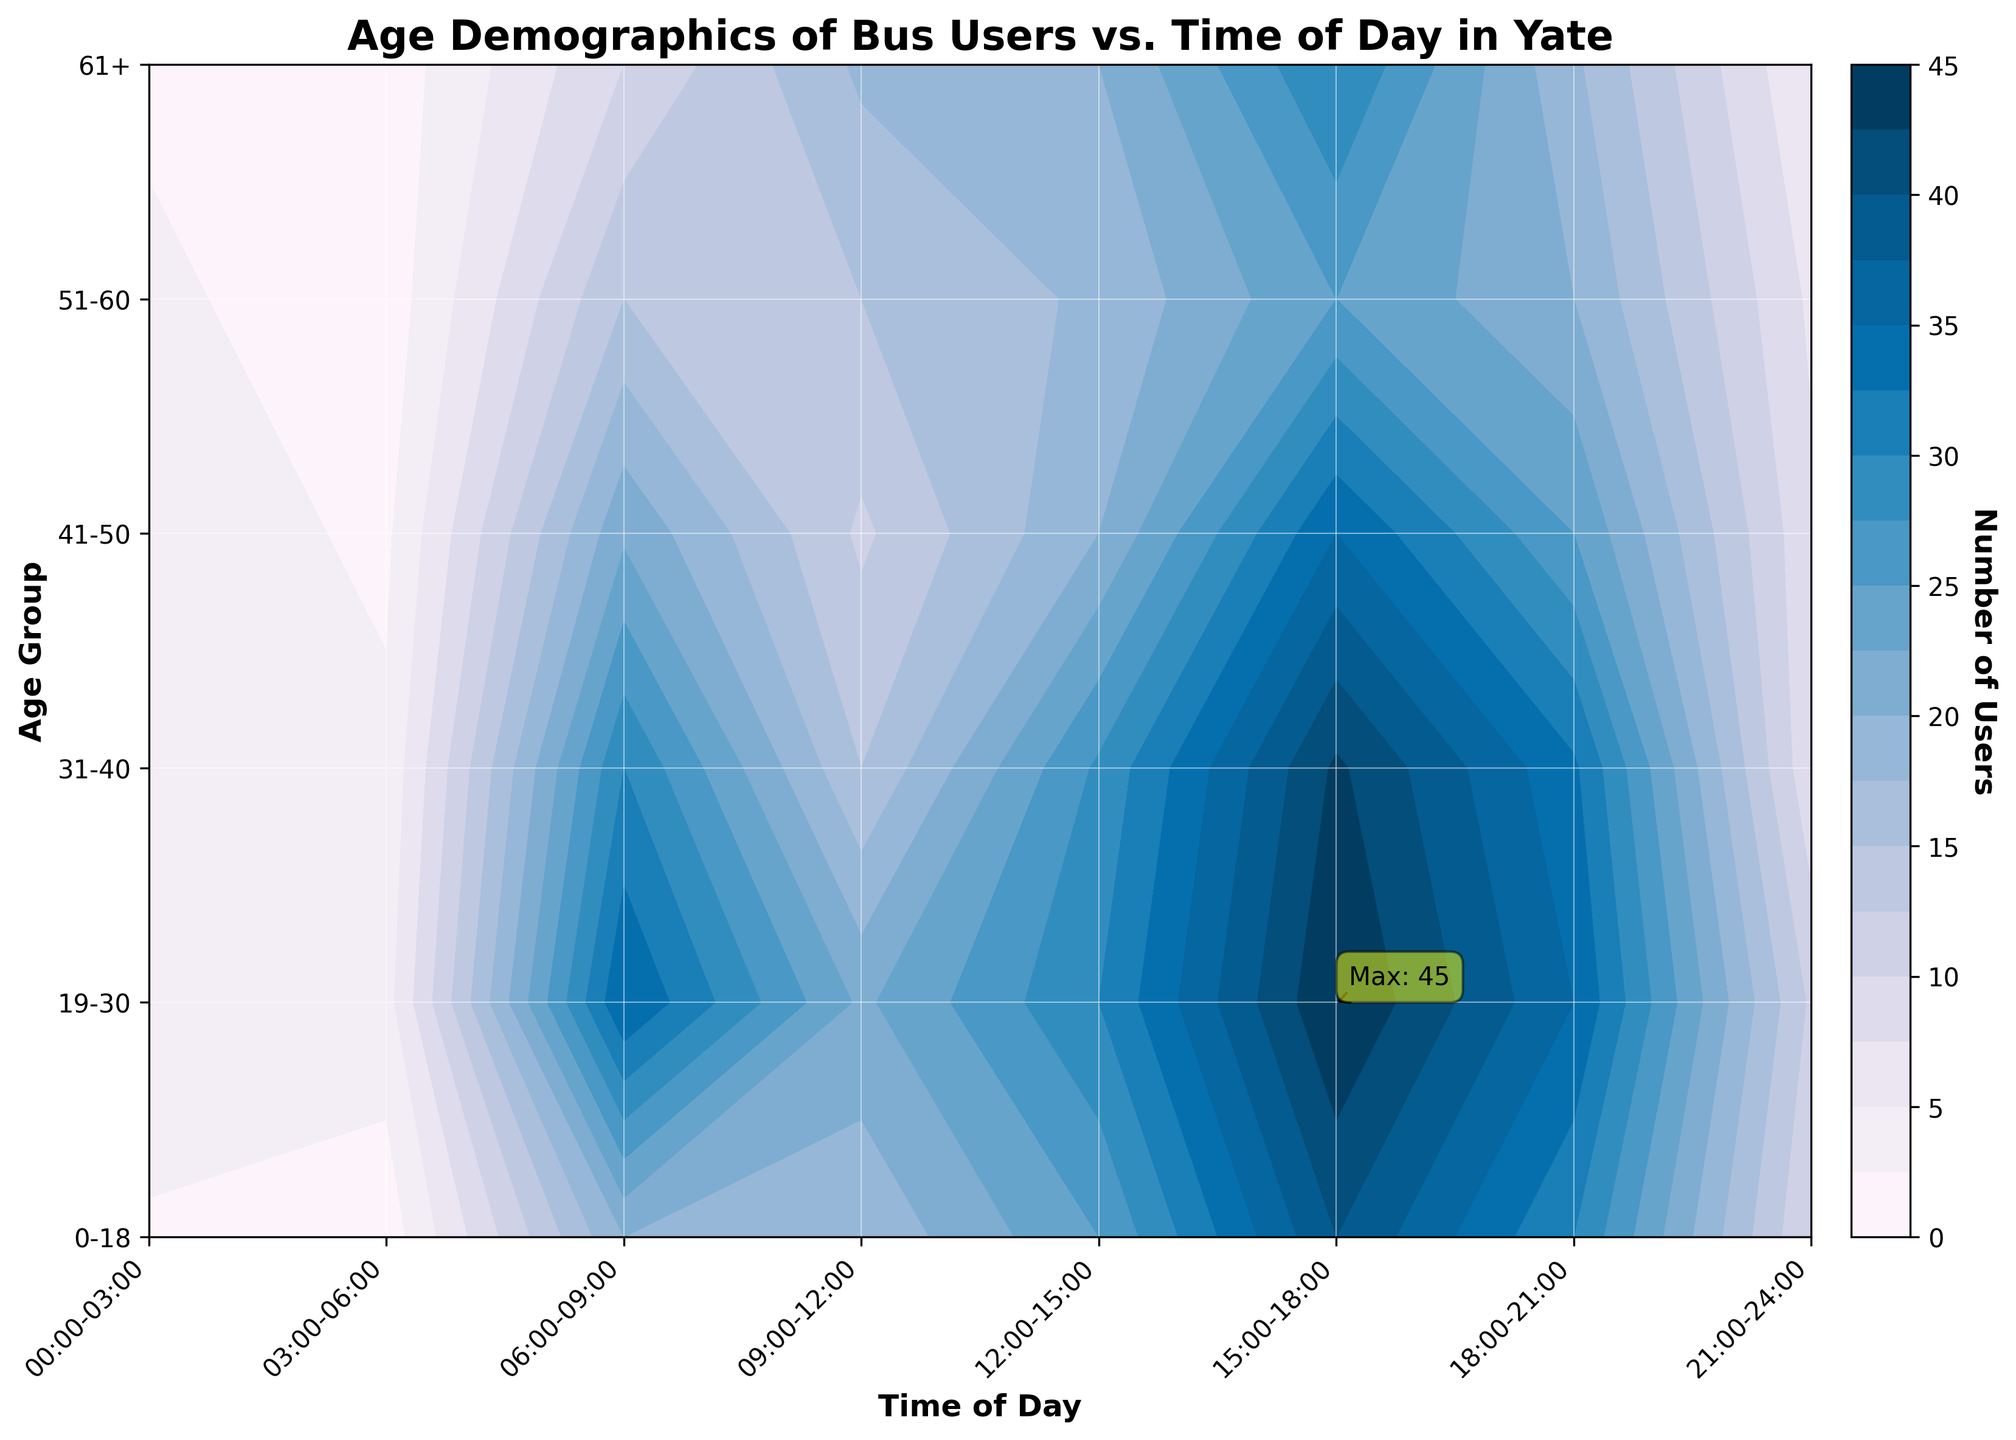Which age group has the highest number of users at 15:00-18:00? To determine which age group has the highest number of users at 15:00-18:00, locate the 15:00-18:00 slot on the x-axis and examine the corresponding y-values for the age groups. The age group with the highest contour level indicates the maximum number of users.
Answer: 19-30 What is the range of time during which 0-18 year-olds have the highest bus usage? Check the contour levels corresponding to the age group 0-18 across all time slots on the x-axis. The time slot with the highest contour level signifies the peak usage.
Answer: 15:00-18:00 At what time of day do users aged 61+ have the lowest bus usage? To find the time when 61+ users have the lowest usage, locate the 61+ age group on the y-axis and identify the time slot with the lowest contour level.
Answer: 03:00-06:00 How does the number of bus users aged 31-40 change from 06:00-09:00 to 18:00-21:00? Compare the contour levels for the age group 31-40 at the time slots 06:00-09:00 and 18:00-21:00. Calculate the difference in user numbers shown by the contour levels.
Answer: Decreases by 3 What is the most popular time slot for bus use across all age groups combined? To find the most popular time slot, observe the contour plot to identify which time slot has the highest overall contour levels across all age groups.
Answer: 15:00-18:00 Which age group has the most consistent bus usage throughout the day? Examine the contour plot to identify the age group whose contour levels are the least varied across different time slots.
Answer: 61+ What is the total number of bus users aged 19-30 from 06:00 to 09:00 and 12:00 to 15:00 combined? Sum the number of users for the 19-30 age group at the time slots 06:00-09:00 and 12:00-15:00. According to the data, the numbers are 35 and 30, respectively, so 35 + 30 = 65.
Answer: 65 Which age group has the highest bus usage during late-night hours (00:00-03:00)? For the time slot 00:00-03:00, locate the contour levels for each age group and identify the highest.
Answer: 19-30 How does the bus usage for the age group 0-18 at 09:00-12:00 compare to that at 12:00-15:00? Compare the contour levels for the age group 0-18 at the time slots 09:00-12:00 and 12:00-15:00. The contour level with a higher value indicates higher usage.
Answer: Lower at 09:00-12:00 During which time slot does the age group 41-50 see a sudden increase in bus usage? Identify the time slot where the contour level for the age group 41-50 significantly increases compared to the previous time slot.
Answer: 15:00-18:00 